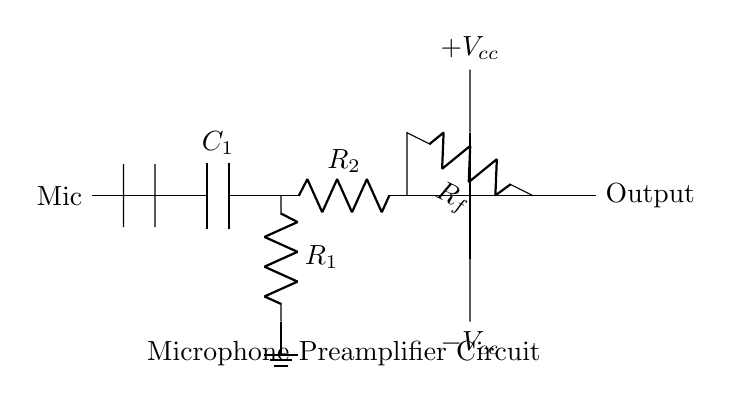What components are present in the circuit? The circuit contains a microphone, capacitors, resistors, and an operational amplifier. Each of these components serves a specific function in processing the audio signal.
Answer: microphone, capacitors, resistors, operational amplifier What is the value of the feedback resistor labeled in the circuit? The feedback resistor is labeled as R sub f. The specific numerical value isn't indicated in the diagram, but its functionality is to control the gain of the operational amplifier.
Answer: R_f What is the purpose of the input capacitor? The input capacitor, labeled as C sub 1, blocks any DC voltage while allowing AC signals, like audio from the microphone, to pass through to the amplifier. This prevents potential damage to the amplifier and ensures it receives only the audio frequency signals.
Answer: blocks DC, allows AC How many resistors are used in this circuit? There are two resistors shown in the circuit, labeled as R sub 1 and R sub 2. These resistors are typically used for biasing and setting the gain in the preamplifier stage.
Answer: 2 What is the expected output of the amplifier? The output is the amplified audio signal from the microphone, which is expected to be significantly higher than the input signal due to the amplification process. The output is marked clearly as "Output" in the circuit diagram.
Answer: amplified audio signal What does the power supply provide to the operational amplifier? The power supply provides positive and negative voltages, denoted as plus V sub cc and minus V sub cc. These voltages are essential for the operational amplifier to function properly and operate within its designated range.
Answer: positive and negative voltages How is the microphone connected to the circuit? The microphone is connected at the input of the circuit, linking directly to C sub 1, which passes the audio signals to the amplifier. This direct connection allows the amplifier to process the audio signals captured by the microphone.
Answer: directly to C_1 